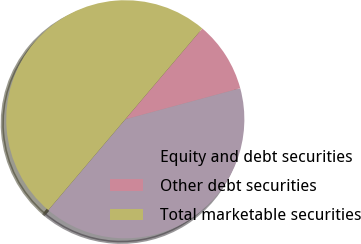Convert chart. <chart><loc_0><loc_0><loc_500><loc_500><pie_chart><fcel>Equity and debt securities<fcel>Other debt securities<fcel>Total marketable securities<nl><fcel>40.39%<fcel>9.61%<fcel>50.0%<nl></chart> 